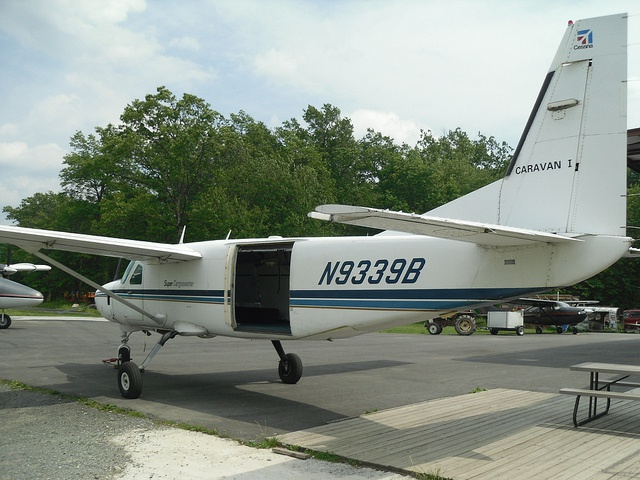Describe the objects in this image and their specific colors. I can see airplane in darkgray, black, gray, and lightgray tones, bench in darkgray, gray, and black tones, airplane in darkgray, gray, black, and white tones, airplane in darkgray, black, gray, and maroon tones, and car in darkgray, black, gray, maroon, and darkgreen tones in this image. 